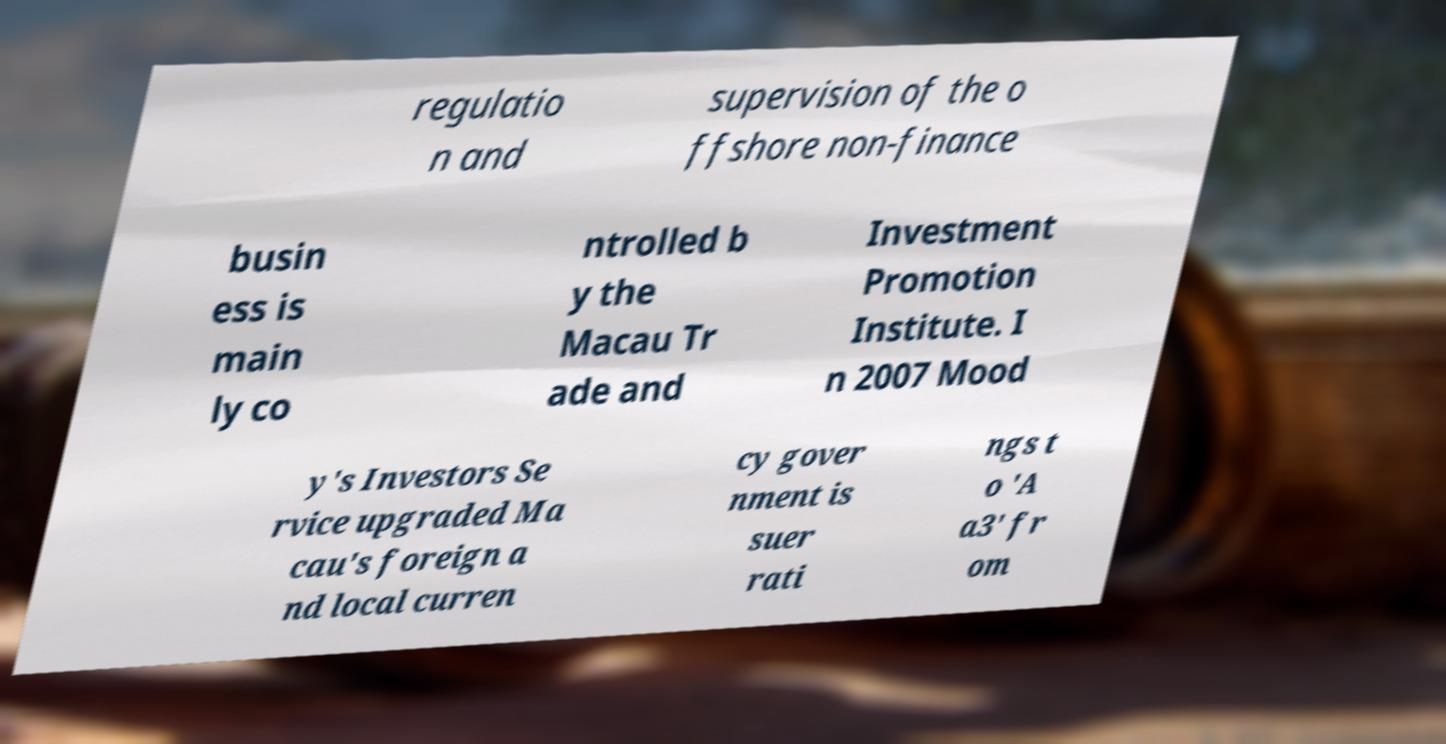I need the written content from this picture converted into text. Can you do that? regulatio n and supervision of the o ffshore non-finance busin ess is main ly co ntrolled b y the Macau Tr ade and Investment Promotion Institute. I n 2007 Mood y's Investors Se rvice upgraded Ma cau's foreign a nd local curren cy gover nment is suer rati ngs t o 'A a3' fr om 